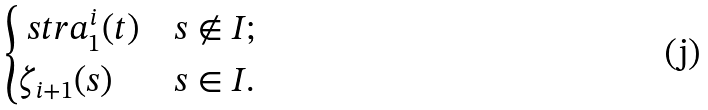Convert formula to latex. <formula><loc_0><loc_0><loc_500><loc_500>\begin{cases} \ s t r a _ { 1 } ^ { i } ( t ) & s \not \in I ; \\ \zeta _ { i + 1 } ( s ) & s \in I . \end{cases}</formula> 